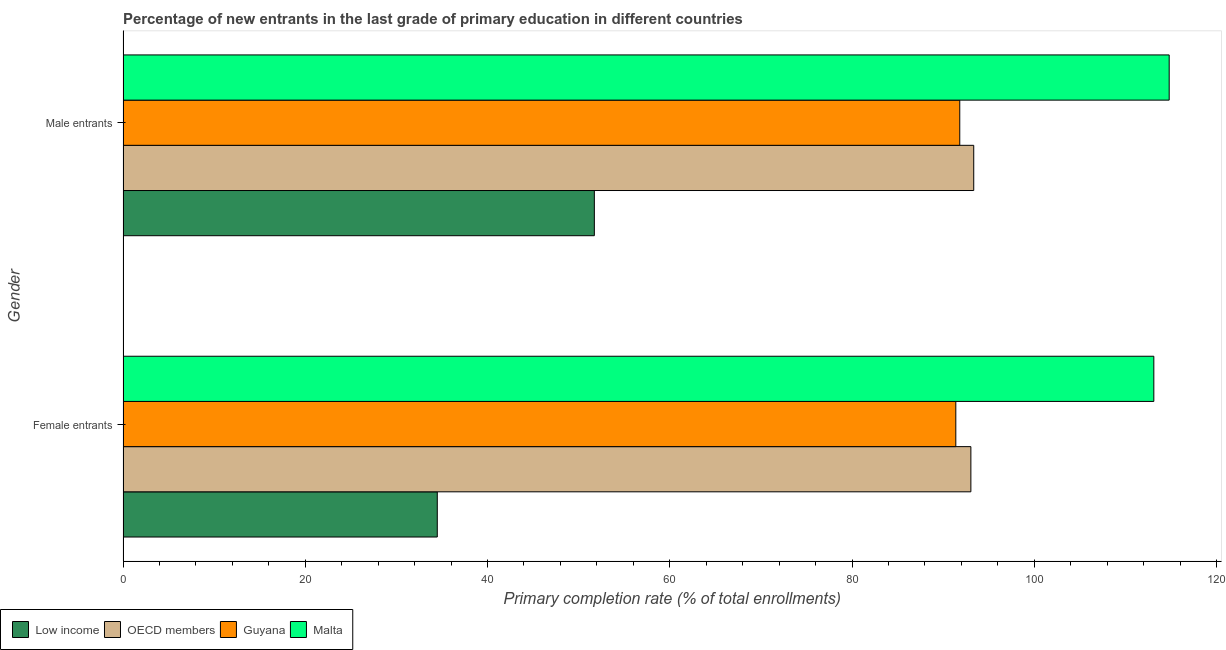How many different coloured bars are there?
Provide a succinct answer. 4. How many groups of bars are there?
Offer a very short reply. 2. Are the number of bars per tick equal to the number of legend labels?
Your answer should be very brief. Yes. How many bars are there on the 2nd tick from the top?
Your answer should be compact. 4. How many bars are there on the 1st tick from the bottom?
Make the answer very short. 4. What is the label of the 1st group of bars from the top?
Offer a very short reply. Male entrants. What is the primary completion rate of male entrants in OECD members?
Provide a short and direct response. 93.35. Across all countries, what is the maximum primary completion rate of female entrants?
Provide a short and direct response. 113.11. Across all countries, what is the minimum primary completion rate of female entrants?
Give a very brief answer. 34.49. In which country was the primary completion rate of male entrants maximum?
Your response must be concise. Malta. What is the total primary completion rate of male entrants in the graph?
Ensure brevity in your answer.  351.69. What is the difference between the primary completion rate of male entrants in Guyana and that in Low income?
Your answer should be compact. 40.1. What is the difference between the primary completion rate of male entrants in OECD members and the primary completion rate of female entrants in Low income?
Your answer should be very brief. 58.86. What is the average primary completion rate of female entrants per country?
Give a very brief answer. 83.01. What is the difference between the primary completion rate of male entrants and primary completion rate of female entrants in Low income?
Keep it short and to the point. 17.23. In how many countries, is the primary completion rate of female entrants greater than 36 %?
Your answer should be very brief. 3. What is the ratio of the primary completion rate of male entrants in Guyana to that in Low income?
Your answer should be very brief. 1.78. Is the primary completion rate of female entrants in Guyana less than that in Malta?
Your response must be concise. Yes. In how many countries, is the primary completion rate of female entrants greater than the average primary completion rate of female entrants taken over all countries?
Make the answer very short. 3. What does the 2nd bar from the top in Female entrants represents?
Keep it short and to the point. Guyana. Are all the bars in the graph horizontal?
Give a very brief answer. Yes. How many countries are there in the graph?
Offer a very short reply. 4. Does the graph contain any zero values?
Make the answer very short. No. Where does the legend appear in the graph?
Provide a succinct answer. Bottom left. What is the title of the graph?
Give a very brief answer. Percentage of new entrants in the last grade of primary education in different countries. Does "Indonesia" appear as one of the legend labels in the graph?
Your answer should be compact. No. What is the label or title of the X-axis?
Your answer should be compact. Primary completion rate (% of total enrollments). What is the label or title of the Y-axis?
Keep it short and to the point. Gender. What is the Primary completion rate (% of total enrollments) of Low income in Female entrants?
Your answer should be very brief. 34.49. What is the Primary completion rate (% of total enrollments) in OECD members in Female entrants?
Provide a short and direct response. 93.04. What is the Primary completion rate (% of total enrollments) of Guyana in Female entrants?
Offer a very short reply. 91.38. What is the Primary completion rate (% of total enrollments) in Malta in Female entrants?
Keep it short and to the point. 113.11. What is the Primary completion rate (% of total enrollments) in Low income in Male entrants?
Offer a terse response. 51.72. What is the Primary completion rate (% of total enrollments) of OECD members in Male entrants?
Your answer should be very brief. 93.35. What is the Primary completion rate (% of total enrollments) in Guyana in Male entrants?
Ensure brevity in your answer.  91.82. What is the Primary completion rate (% of total enrollments) in Malta in Male entrants?
Offer a very short reply. 114.8. Across all Gender, what is the maximum Primary completion rate (% of total enrollments) in Low income?
Your response must be concise. 51.72. Across all Gender, what is the maximum Primary completion rate (% of total enrollments) of OECD members?
Give a very brief answer. 93.35. Across all Gender, what is the maximum Primary completion rate (% of total enrollments) of Guyana?
Your answer should be very brief. 91.82. Across all Gender, what is the maximum Primary completion rate (% of total enrollments) in Malta?
Ensure brevity in your answer.  114.8. Across all Gender, what is the minimum Primary completion rate (% of total enrollments) in Low income?
Your response must be concise. 34.49. Across all Gender, what is the minimum Primary completion rate (% of total enrollments) of OECD members?
Offer a terse response. 93.04. Across all Gender, what is the minimum Primary completion rate (% of total enrollments) of Guyana?
Ensure brevity in your answer.  91.38. Across all Gender, what is the minimum Primary completion rate (% of total enrollments) of Malta?
Offer a very short reply. 113.11. What is the total Primary completion rate (% of total enrollments) of Low income in the graph?
Provide a succinct answer. 86.21. What is the total Primary completion rate (% of total enrollments) of OECD members in the graph?
Provide a short and direct response. 186.39. What is the total Primary completion rate (% of total enrollments) in Guyana in the graph?
Offer a terse response. 183.2. What is the total Primary completion rate (% of total enrollments) of Malta in the graph?
Keep it short and to the point. 227.91. What is the difference between the Primary completion rate (% of total enrollments) of Low income in Female entrants and that in Male entrants?
Your answer should be very brief. -17.23. What is the difference between the Primary completion rate (% of total enrollments) in OECD members in Female entrants and that in Male entrants?
Provide a succinct answer. -0.31. What is the difference between the Primary completion rate (% of total enrollments) of Guyana in Female entrants and that in Male entrants?
Offer a very short reply. -0.43. What is the difference between the Primary completion rate (% of total enrollments) of Malta in Female entrants and that in Male entrants?
Make the answer very short. -1.69. What is the difference between the Primary completion rate (% of total enrollments) in Low income in Female entrants and the Primary completion rate (% of total enrollments) in OECD members in Male entrants?
Offer a very short reply. -58.86. What is the difference between the Primary completion rate (% of total enrollments) of Low income in Female entrants and the Primary completion rate (% of total enrollments) of Guyana in Male entrants?
Your answer should be very brief. -57.33. What is the difference between the Primary completion rate (% of total enrollments) of Low income in Female entrants and the Primary completion rate (% of total enrollments) of Malta in Male entrants?
Ensure brevity in your answer.  -80.31. What is the difference between the Primary completion rate (% of total enrollments) in OECD members in Female entrants and the Primary completion rate (% of total enrollments) in Guyana in Male entrants?
Your response must be concise. 1.22. What is the difference between the Primary completion rate (% of total enrollments) of OECD members in Female entrants and the Primary completion rate (% of total enrollments) of Malta in Male entrants?
Offer a terse response. -21.76. What is the difference between the Primary completion rate (% of total enrollments) in Guyana in Female entrants and the Primary completion rate (% of total enrollments) in Malta in Male entrants?
Give a very brief answer. -23.41. What is the average Primary completion rate (% of total enrollments) of Low income per Gender?
Make the answer very short. 43.1. What is the average Primary completion rate (% of total enrollments) in OECD members per Gender?
Keep it short and to the point. 93.19. What is the average Primary completion rate (% of total enrollments) of Guyana per Gender?
Provide a succinct answer. 91.6. What is the average Primary completion rate (% of total enrollments) in Malta per Gender?
Keep it short and to the point. 113.95. What is the difference between the Primary completion rate (% of total enrollments) in Low income and Primary completion rate (% of total enrollments) in OECD members in Female entrants?
Offer a very short reply. -58.55. What is the difference between the Primary completion rate (% of total enrollments) in Low income and Primary completion rate (% of total enrollments) in Guyana in Female entrants?
Ensure brevity in your answer.  -56.9. What is the difference between the Primary completion rate (% of total enrollments) in Low income and Primary completion rate (% of total enrollments) in Malta in Female entrants?
Offer a very short reply. -78.63. What is the difference between the Primary completion rate (% of total enrollments) of OECD members and Primary completion rate (% of total enrollments) of Guyana in Female entrants?
Ensure brevity in your answer.  1.65. What is the difference between the Primary completion rate (% of total enrollments) in OECD members and Primary completion rate (% of total enrollments) in Malta in Female entrants?
Provide a succinct answer. -20.07. What is the difference between the Primary completion rate (% of total enrollments) in Guyana and Primary completion rate (% of total enrollments) in Malta in Female entrants?
Provide a short and direct response. -21.73. What is the difference between the Primary completion rate (% of total enrollments) of Low income and Primary completion rate (% of total enrollments) of OECD members in Male entrants?
Your response must be concise. -41.63. What is the difference between the Primary completion rate (% of total enrollments) in Low income and Primary completion rate (% of total enrollments) in Guyana in Male entrants?
Give a very brief answer. -40.1. What is the difference between the Primary completion rate (% of total enrollments) in Low income and Primary completion rate (% of total enrollments) in Malta in Male entrants?
Provide a short and direct response. -63.08. What is the difference between the Primary completion rate (% of total enrollments) of OECD members and Primary completion rate (% of total enrollments) of Guyana in Male entrants?
Provide a short and direct response. 1.53. What is the difference between the Primary completion rate (% of total enrollments) of OECD members and Primary completion rate (% of total enrollments) of Malta in Male entrants?
Offer a very short reply. -21.45. What is the difference between the Primary completion rate (% of total enrollments) of Guyana and Primary completion rate (% of total enrollments) of Malta in Male entrants?
Your answer should be very brief. -22.98. What is the ratio of the Primary completion rate (% of total enrollments) in Low income in Female entrants to that in Male entrants?
Your response must be concise. 0.67. What is the ratio of the Primary completion rate (% of total enrollments) in OECD members in Female entrants to that in Male entrants?
Offer a terse response. 1. What is the ratio of the Primary completion rate (% of total enrollments) of Malta in Female entrants to that in Male entrants?
Provide a short and direct response. 0.99. What is the difference between the highest and the second highest Primary completion rate (% of total enrollments) in Low income?
Offer a terse response. 17.23. What is the difference between the highest and the second highest Primary completion rate (% of total enrollments) in OECD members?
Give a very brief answer. 0.31. What is the difference between the highest and the second highest Primary completion rate (% of total enrollments) of Guyana?
Give a very brief answer. 0.43. What is the difference between the highest and the second highest Primary completion rate (% of total enrollments) in Malta?
Your response must be concise. 1.69. What is the difference between the highest and the lowest Primary completion rate (% of total enrollments) of Low income?
Your response must be concise. 17.23. What is the difference between the highest and the lowest Primary completion rate (% of total enrollments) of OECD members?
Your response must be concise. 0.31. What is the difference between the highest and the lowest Primary completion rate (% of total enrollments) of Guyana?
Provide a short and direct response. 0.43. What is the difference between the highest and the lowest Primary completion rate (% of total enrollments) of Malta?
Ensure brevity in your answer.  1.69. 